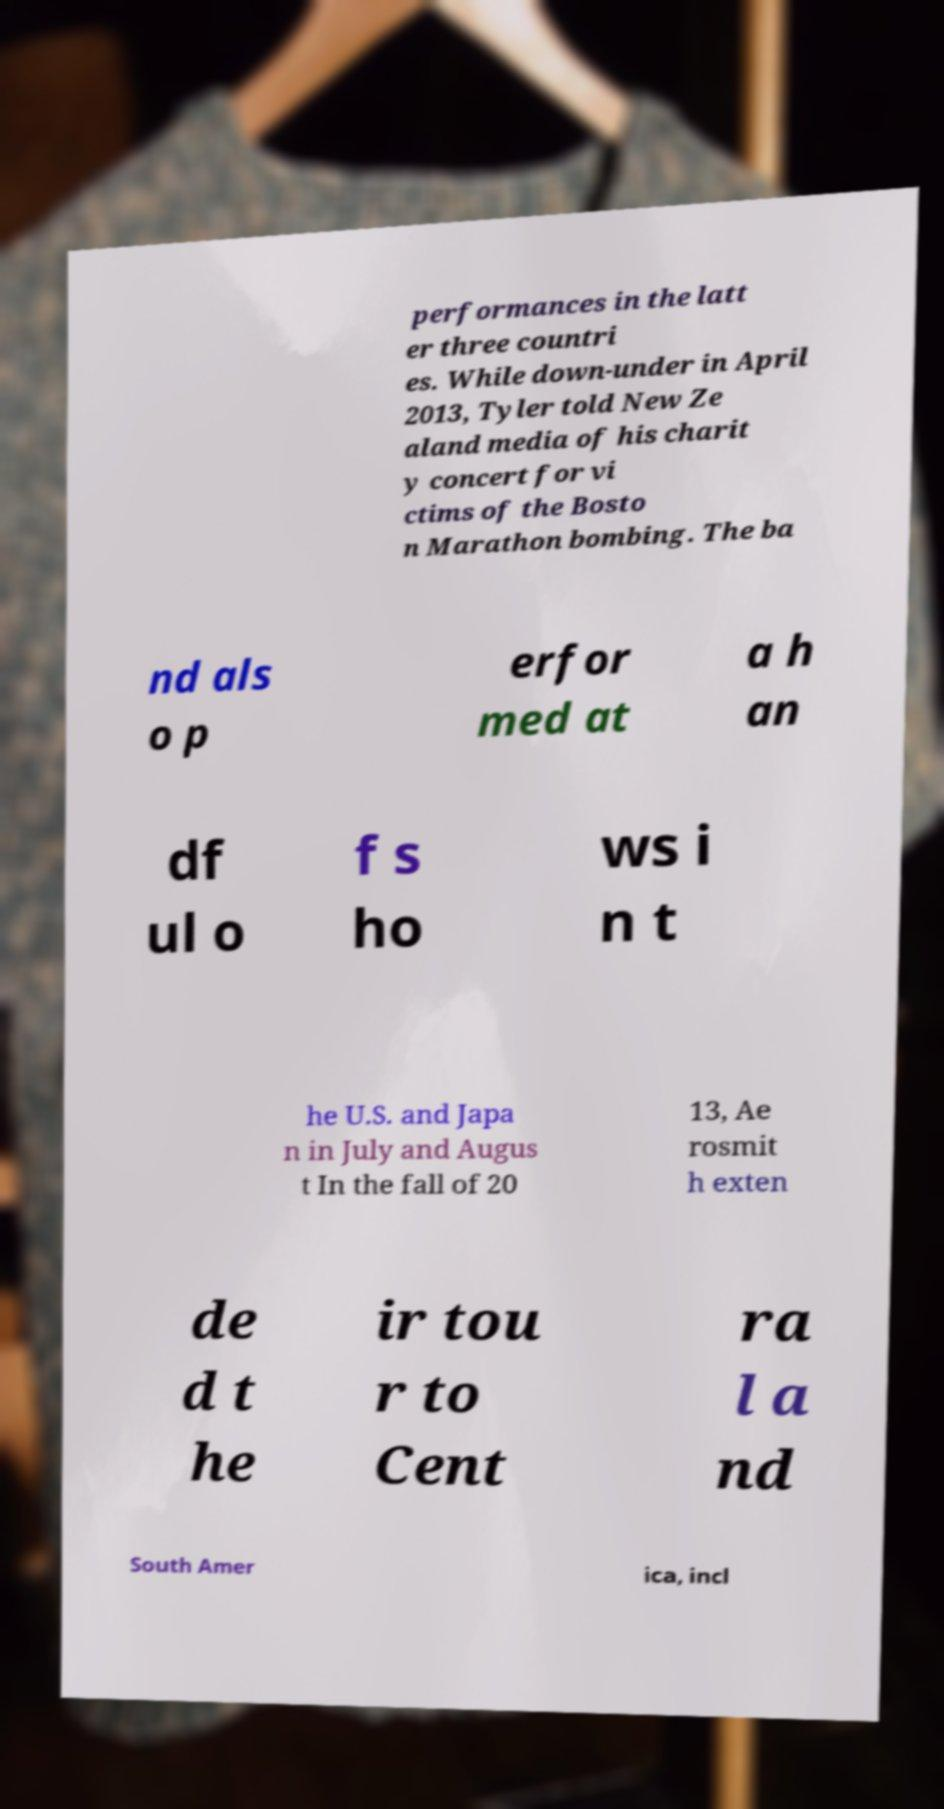Could you assist in decoding the text presented in this image and type it out clearly? performances in the latt er three countri es. While down-under in April 2013, Tyler told New Ze aland media of his charit y concert for vi ctims of the Bosto n Marathon bombing. The ba nd als o p erfor med at a h an df ul o f s ho ws i n t he U.S. and Japa n in July and Augus t In the fall of 20 13, Ae rosmit h exten de d t he ir tou r to Cent ra l a nd South Amer ica, incl 